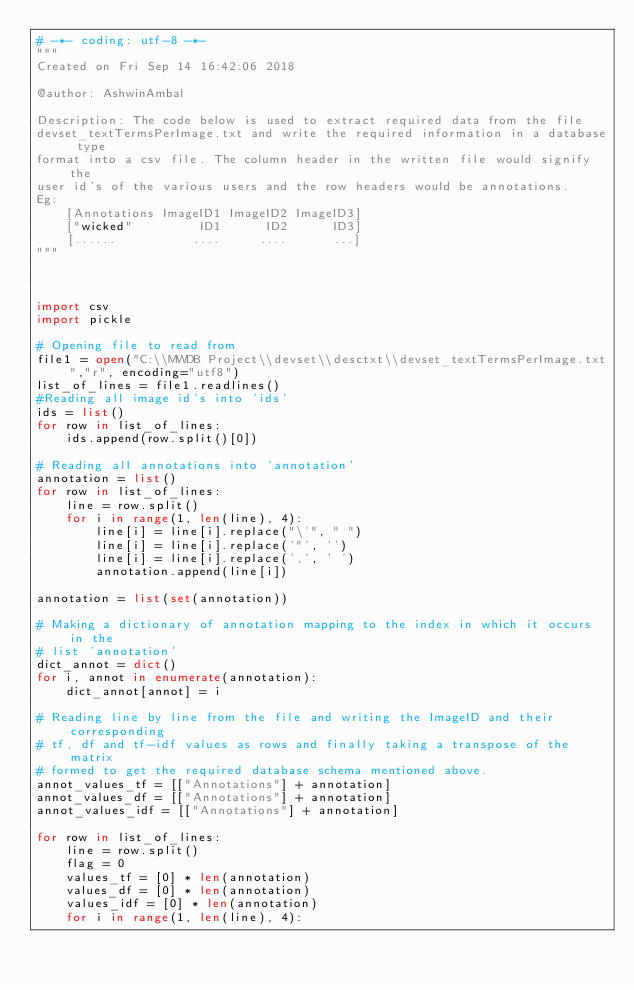<code> <loc_0><loc_0><loc_500><loc_500><_Python_># -*- coding: utf-8 -*-
"""
Created on Fri Sep 14 16:42:06 2018

@author: AshwinAmbal

Description: The code below is used to extract required data from the file 
devset_textTermsPerImage.txt and write the required information in a database type
format into a csv file. The column header in the written file would signify the
user id's of the various users and the row headers would be annotations.
Eg:
    [Annotations ImageID1 ImageID2 ImageID3]
    ["wicked"         ID1      ID2      ID3]
    [......          ....     ....      ...]
"""



import csv
import pickle

# Opening file to read from
file1 = open("C:\\MWDB Project\\devset\\desctxt\\devset_textTermsPerImage.txt","r", encoding="utf8")
list_of_lines = file1.readlines()
#Reading all image id's into 'ids'
ids = list()
for row in list_of_lines:
    ids.append(row.split()[0])

# Reading all annotations into 'annotation'
annotation = list()
for row in list_of_lines:
    line = row.split()
    for i in range(1, len(line), 4):
        line[i] = line[i].replace("\'", " ")
        line[i] = line[i].replace('"', '')
        line[i] = line[i].replace(',', ' ')
        annotation.append(line[i])

annotation = list(set(annotation))

# Making a dictionary of annotation mapping to the index in which it occurs in the
# list 'annotation'
dict_annot = dict()
for i, annot in enumerate(annotation):
    dict_annot[annot] = i

# Reading line by line from the file and writing the ImageID and their corresponding
# tf, df and tf-idf values as rows and finally taking a transpose of the matrix
# formed to get the required database schema mentioned above.
annot_values_tf = [["Annotations"] + annotation]
annot_values_df = [["Annotations"] + annotation]
annot_values_idf = [["Annotations"] + annotation]

for row in list_of_lines:
    line = row.split()
    flag = 0
    values_tf = [0] * len(annotation)
    values_df = [0] * len(annotation)
    values_idf = [0] * len(annotation)
    for i in range(1, len(line), 4):</code> 